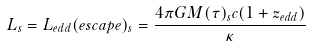Convert formula to latex. <formula><loc_0><loc_0><loc_500><loc_500>L _ { s } = L _ { e d d } ( e s c a p e ) _ { s } = \frac { 4 \pi G M ( \tau ) _ { s } c ( 1 + z _ { e d d } ) } { \kappa }</formula> 